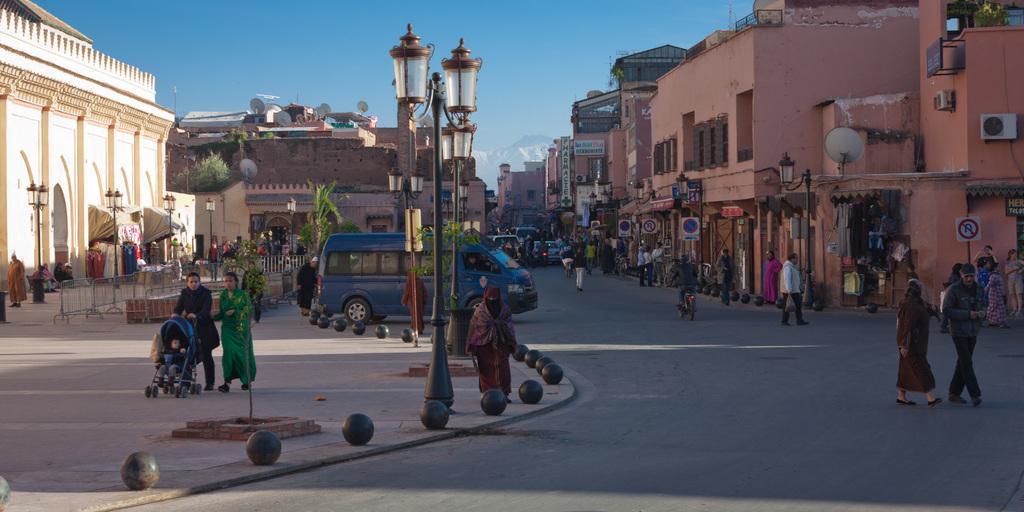Could you give a brief overview of what you see in this image? In this image there is a road in the middle. On the road there are so many vehicles. There are buildings on either side of the road. At the top there is the sky. On the left side there are two persons who are walking on the floor by holding the cradle. On the footpath there is a van. There are few people walking on the footpath. On the footpath there are black colour balls one after the other. In the middle there is a light pole. There are buildings all over the place. 